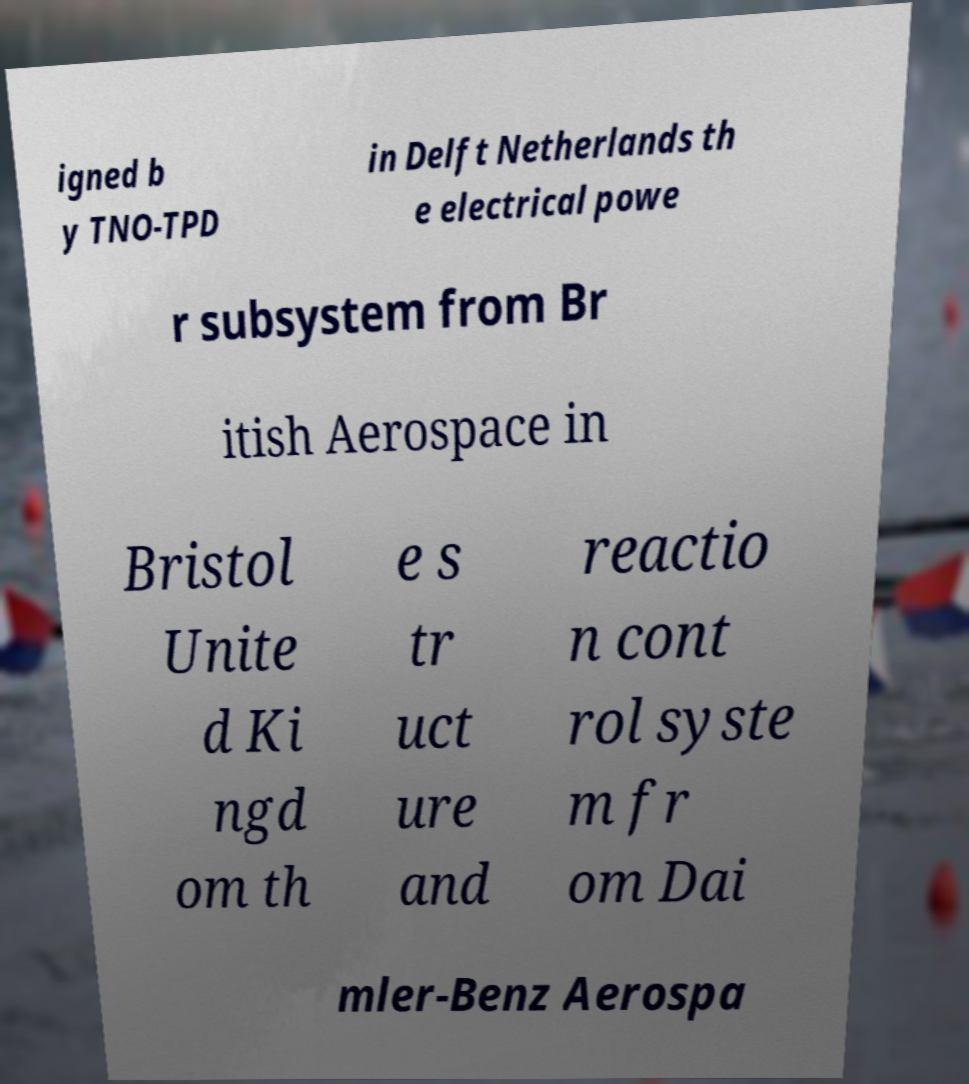Can you read and provide the text displayed in the image?This photo seems to have some interesting text. Can you extract and type it out for me? igned b y TNO-TPD in Delft Netherlands th e electrical powe r subsystem from Br itish Aerospace in Bristol Unite d Ki ngd om th e s tr uct ure and reactio n cont rol syste m fr om Dai mler-Benz Aerospa 